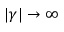<formula> <loc_0><loc_0><loc_500><loc_500>| \gamma | \rightarrow \infty</formula> 